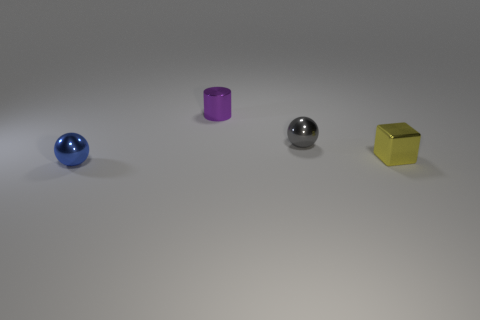Is the number of metal cylinders behind the small gray thing the same as the number of small metal spheres left of the small yellow shiny block?
Offer a terse response. No. The cylinder that is the same material as the cube is what color?
Offer a very short reply. Purple. Do the small metal cylinder and the tiny metal ball that is in front of the tiny gray thing have the same color?
Make the answer very short. No. There is a yellow thing that is behind the metallic thing in front of the yellow block; is there a tiny purple cylinder that is to the left of it?
Provide a succinct answer. Yes. There is a gray thing that is the same material as the small blue sphere; what shape is it?
Your answer should be very brief. Sphere. Are there any other things that are the same shape as the yellow metal thing?
Give a very brief answer. No. There is a small gray thing; what shape is it?
Make the answer very short. Sphere. There is a small object that is in front of the metallic block; does it have the same shape as the small yellow metal thing?
Your response must be concise. No. Are there more tiny balls behind the metallic cylinder than tiny purple metallic things that are in front of the gray thing?
Provide a short and direct response. No. What number of other objects are there of the same size as the cylinder?
Provide a succinct answer. 3. 